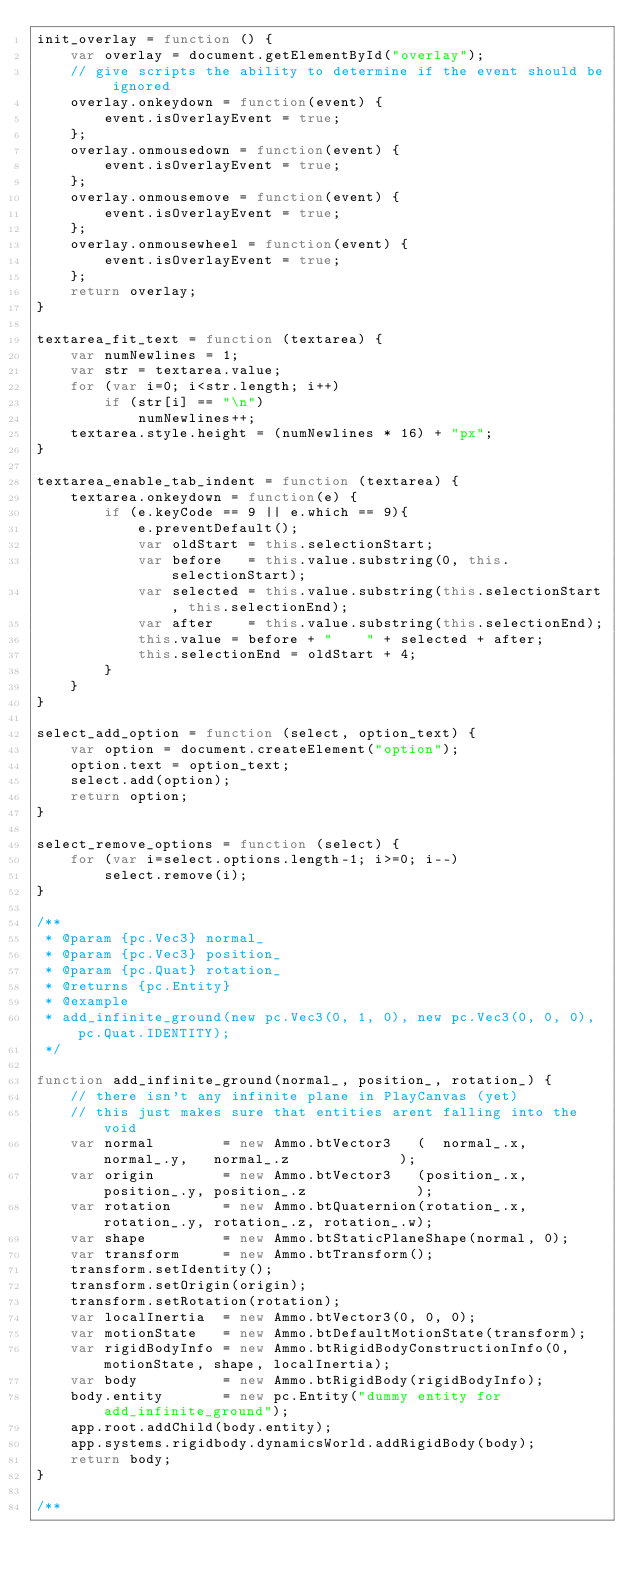Convert code to text. <code><loc_0><loc_0><loc_500><loc_500><_JavaScript_>init_overlay = function () {
    var overlay = document.getElementById("overlay");
    // give scripts the ability to determine if the event should be ignored
    overlay.onkeydown = function(event) {
        event.isOverlayEvent = true;
    };
    overlay.onmousedown = function(event) {
        event.isOverlayEvent = true;
    };
    overlay.onmousemove = function(event) {
        event.isOverlayEvent = true;
    };
    overlay.onmousewheel = function(event) {
        event.isOverlayEvent = true;
    };
    return overlay;
}

textarea_fit_text = function (textarea) {    
    var numNewlines = 1;
    var str = textarea.value;
    for (var i=0; i<str.length; i++)
        if (str[i] == "\n")
            numNewlines++;
    textarea.style.height = (numNewlines * 16) + "px";
}

textarea_enable_tab_indent = function (textarea) {    
    textarea.onkeydown = function(e) {
        if (e.keyCode == 9 || e.which == 9){
            e.preventDefault();
            var oldStart = this.selectionStart;
            var before   = this.value.substring(0, this.selectionStart);
            var selected = this.value.substring(this.selectionStart, this.selectionEnd);
            var after    = this.value.substring(this.selectionEnd);
            this.value = before + "    " + selected + after;
            this.selectionEnd = oldStart + 4;
        }
    }
}

select_add_option = function (select, option_text) {
    var option = document.createElement("option");
    option.text = option_text;
    select.add(option);
    return option;
}

select_remove_options = function (select) {
    for (var i=select.options.length-1; i>=0; i--)
        select.remove(i);
}

/**
 * @param {pc.Vec3} normal_ 
 * @param {pc.Vec3} position_ 
 * @param {pc.Quat} rotation_ 
 * @returns {pc.Entity}
 * @example
 * add_infinite_ground(new pc.Vec3(0, 1, 0), new pc.Vec3(0, 0, 0), pc.Quat.IDENTITY);
 */

function add_infinite_ground(normal_, position_, rotation_) {
    // there isn't any infinite plane in PlayCanvas (yet)
    // this just makes sure that entities arent falling into the void
    var normal        = new Ammo.btVector3   (  normal_.x,   normal_.y,   normal_.z             );
    var origin        = new Ammo.btVector3   (position_.x, position_.y, position_.z             );
    var rotation      = new Ammo.btQuaternion(rotation_.x, rotation_.y, rotation_.z, rotation_.w);
    var shape         = new Ammo.btStaticPlaneShape(normal, 0);
    var transform     = new Ammo.btTransform();
    transform.setIdentity();
    transform.setOrigin(origin);
    transform.setRotation(rotation);
    var localInertia  = new Ammo.btVector3(0, 0, 0);
    var motionState   = new Ammo.btDefaultMotionState(transform);
    var rigidBodyInfo = new Ammo.btRigidBodyConstructionInfo(0, motionState, shape, localInertia);
    var body          = new Ammo.btRigidBody(rigidBodyInfo);
    body.entity       = new pc.Entity("dummy entity for add_infinite_ground");
    app.root.addChild(body.entity);
    app.systems.rigidbody.dynamicsWorld.addRigidBody(body);
    return body;
}

/**</code> 